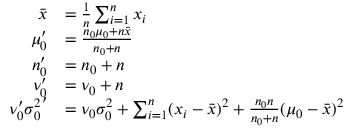Convert formula to latex. <formula><loc_0><loc_0><loc_500><loc_500>{ \begin{array} { r l } { { \bar { x } } } & { = { \frac { 1 } { n } } \sum _ { i = 1 } ^ { n } x _ { i } } \\ { \mu _ { 0 } ^ { \prime } } & { = { \frac { n _ { 0 } \mu _ { 0 } + n { \bar { x } } } { n _ { 0 } + n } } } \\ { n _ { 0 } ^ { \prime } } & { = n _ { 0 } + n } \\ { \nu _ { 0 } ^ { \prime } } & { = \nu _ { 0 } + n } \\ { \nu _ { 0 } ^ { \prime } { \sigma _ { 0 } ^ { 2 } } ^ { \prime } } & { = \nu _ { 0 } \sigma _ { 0 } ^ { 2 } + \sum _ { i = 1 } ^ { n } ( x _ { i } - { \bar { x } } ) ^ { 2 } + { \frac { n _ { 0 } n } { n _ { 0 } + n } } ( \mu _ { 0 } - { \bar { x } } ) ^ { 2 } } \end{array} }</formula> 